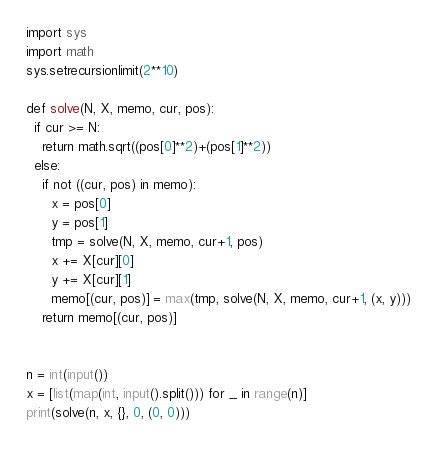Convert code to text. <code><loc_0><loc_0><loc_500><loc_500><_Python_>import sys
import math
sys.setrecursionlimit(2**10)

def solve(N, X, memo, cur, pos):
  if cur >= N:
    return math.sqrt((pos[0]**2)+(pos[1]**2))
  else:
    if not ((cur, pos) in memo):
      x = pos[0]
      y = pos[1]
      tmp = solve(N, X, memo, cur+1, pos)
      x += X[cur][0]
      y += X[cur][1]
      memo[(cur, pos)] = max(tmp, solve(N, X, memo, cur+1, (x, y)))
    return memo[(cur, pos)]


n = int(input())
x = [list(map(int, input().split())) for _ in range(n)]
print(solve(n, x, {}, 0, (0, 0)))

</code> 